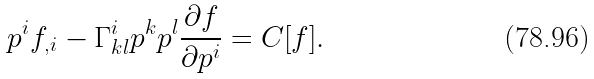<formula> <loc_0><loc_0><loc_500><loc_500>p ^ { i } f _ { , i } - \Gamma ^ { i } _ { k l } p ^ { k } p ^ { l } \frac { \partial f } { \partial p ^ { i } } = C [ f ] .</formula> 